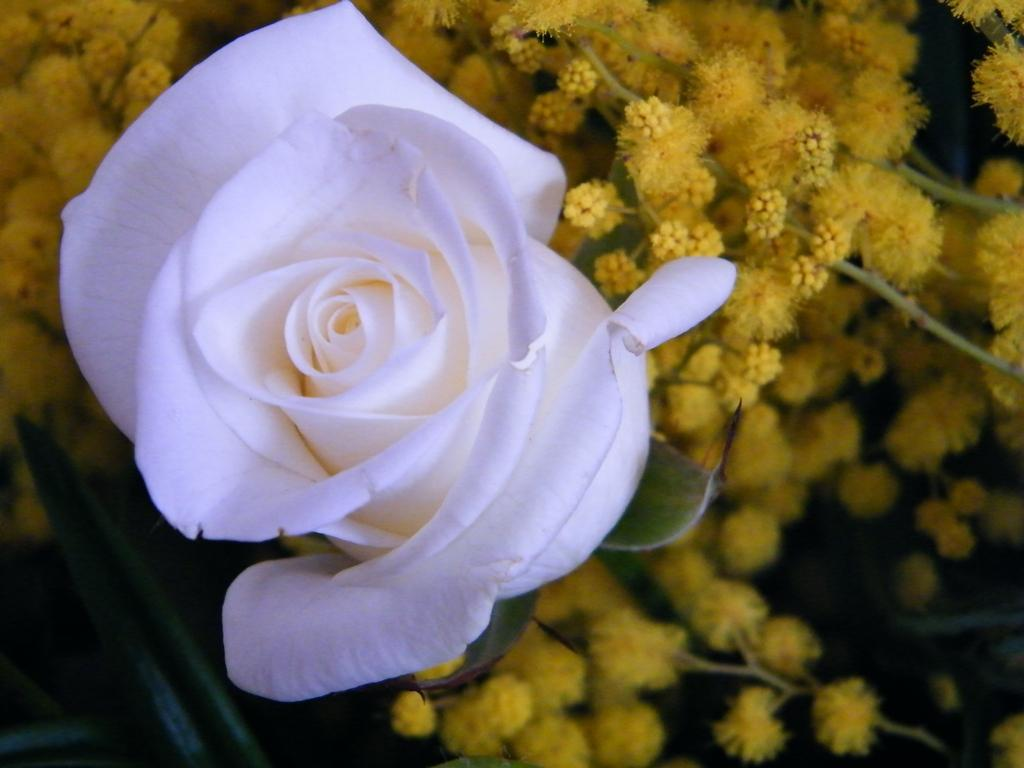What type of flower is in the foreground of the image? There is a white rose in the foreground of the image. What colors are the flowers behind the white rose? The flowers behind the white rose are yellow. Can you describe the arrangement of the flowers in the image? The white rose is in the foreground, and the yellow flowers are behind it. What magical effect does the wind have on the flowers in the image? There is no mention of wind or magic in the image, so we cannot determine any magical effects on the flowers. 